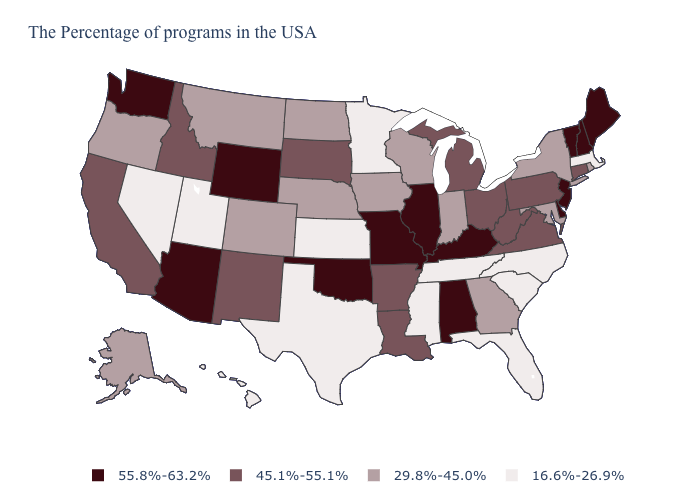What is the value of Kentucky?
Be succinct. 55.8%-63.2%. What is the value of South Carolina?
Answer briefly. 16.6%-26.9%. What is the value of Indiana?
Concise answer only. 29.8%-45.0%. Does Colorado have the same value as Iowa?
Be succinct. Yes. What is the value of Wyoming?
Quick response, please. 55.8%-63.2%. Which states have the lowest value in the USA?
Write a very short answer. Massachusetts, North Carolina, South Carolina, Florida, Tennessee, Mississippi, Minnesota, Kansas, Texas, Utah, Nevada, Hawaii. Name the states that have a value in the range 29.8%-45.0%?
Quick response, please. Rhode Island, New York, Maryland, Georgia, Indiana, Wisconsin, Iowa, Nebraska, North Dakota, Colorado, Montana, Oregon, Alaska. Name the states that have a value in the range 45.1%-55.1%?
Keep it brief. Connecticut, Pennsylvania, Virginia, West Virginia, Ohio, Michigan, Louisiana, Arkansas, South Dakota, New Mexico, Idaho, California. Name the states that have a value in the range 16.6%-26.9%?
Short answer required. Massachusetts, North Carolina, South Carolina, Florida, Tennessee, Mississippi, Minnesota, Kansas, Texas, Utah, Nevada, Hawaii. Does Mississippi have the same value as Wyoming?
Short answer required. No. What is the value of Illinois?
Write a very short answer. 55.8%-63.2%. Does Massachusetts have the highest value in the Northeast?
Quick response, please. No. How many symbols are there in the legend?
Quick response, please. 4. Among the states that border Maine , which have the highest value?
Quick response, please. New Hampshire. Is the legend a continuous bar?
Be succinct. No. 